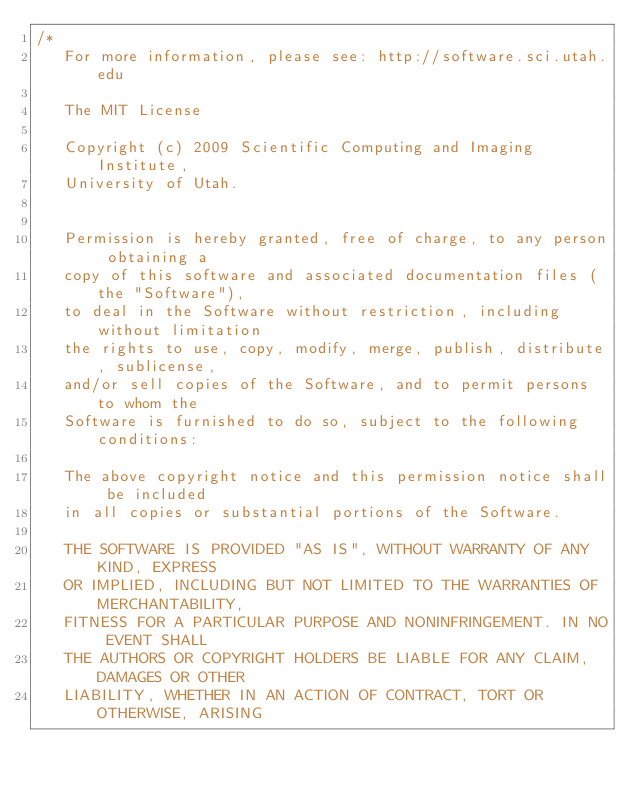<code> <loc_0><loc_0><loc_500><loc_500><_C++_>/*
   For more information, please see: http://software.sci.utah.edu

   The MIT License

   Copyright (c) 2009 Scientific Computing and Imaging Institute,
   University of Utah.


   Permission is hereby granted, free of charge, to any person obtaining a
   copy of this software and associated documentation files (the "Software"),
   to deal in the Software without restriction, including without limitation
   the rights to use, copy, modify, merge, publish, distribute, sublicense,
   and/or sell copies of the Software, and to permit persons to whom the
   Software is furnished to do so, subject to the following conditions:

   The above copyright notice and this permission notice shall be included
   in all copies or substantial portions of the Software.

   THE SOFTWARE IS PROVIDED "AS IS", WITHOUT WARRANTY OF ANY KIND, EXPRESS
   OR IMPLIED, INCLUDING BUT NOT LIMITED TO THE WARRANTIES OF MERCHANTABILITY,
   FITNESS FOR A PARTICULAR PURPOSE AND NONINFRINGEMENT. IN NO EVENT SHALL
   THE AUTHORS OR COPYRIGHT HOLDERS BE LIABLE FOR ANY CLAIM, DAMAGES OR OTHER
   LIABILITY, WHETHER IN AN ACTION OF CONTRACT, TORT OR OTHERWISE, ARISING</code> 